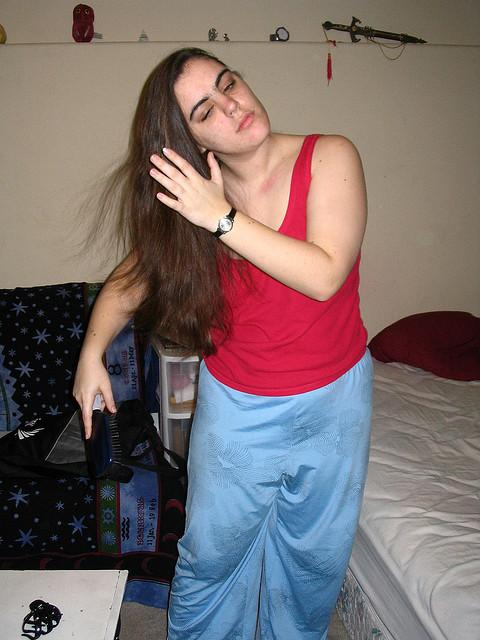What item hanging on the wall would help most on a battlefield? Please explain your reasoning. dagger. The knife on the wall could be used in a combat situation. 